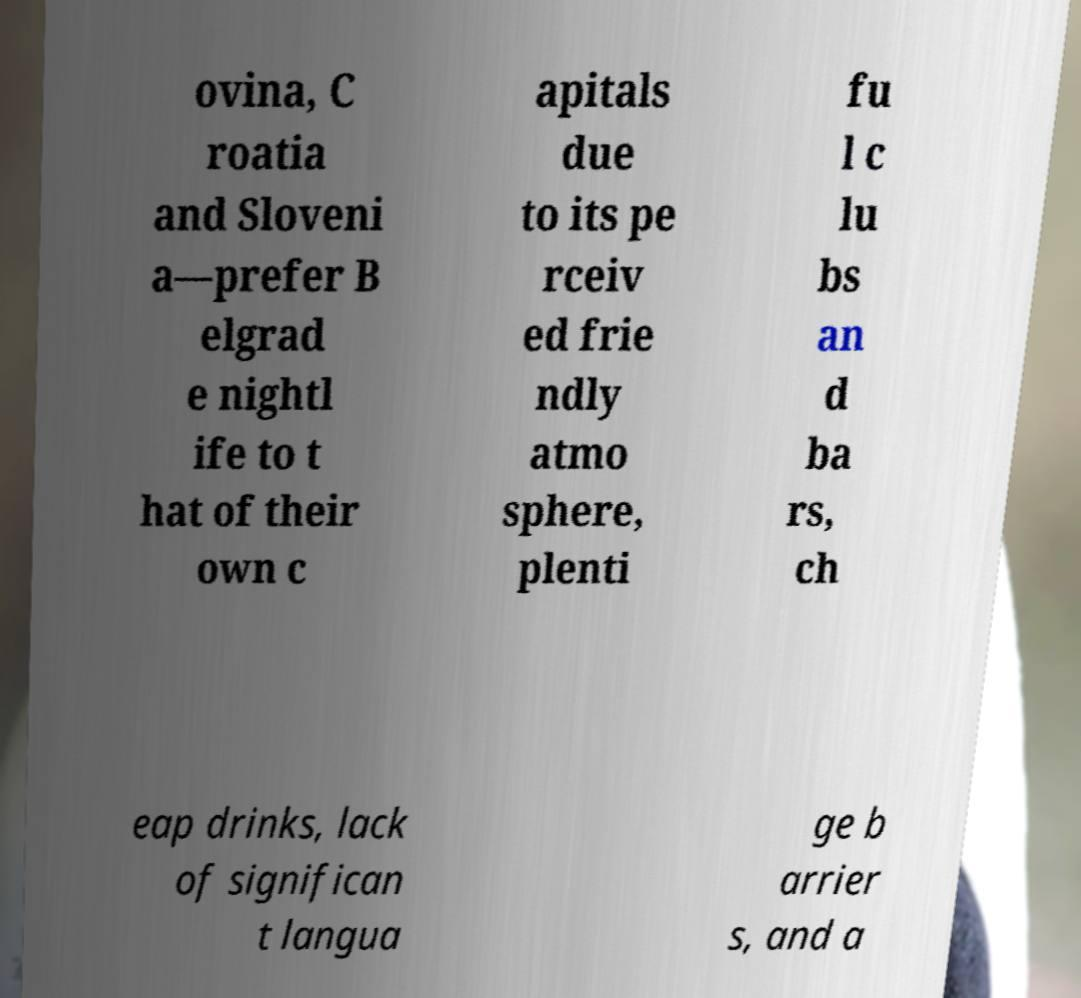Can you accurately transcribe the text from the provided image for me? ovina, C roatia and Sloveni a—prefer B elgrad e nightl ife to t hat of their own c apitals due to its pe rceiv ed frie ndly atmo sphere, plenti fu l c lu bs an d ba rs, ch eap drinks, lack of significan t langua ge b arrier s, and a 